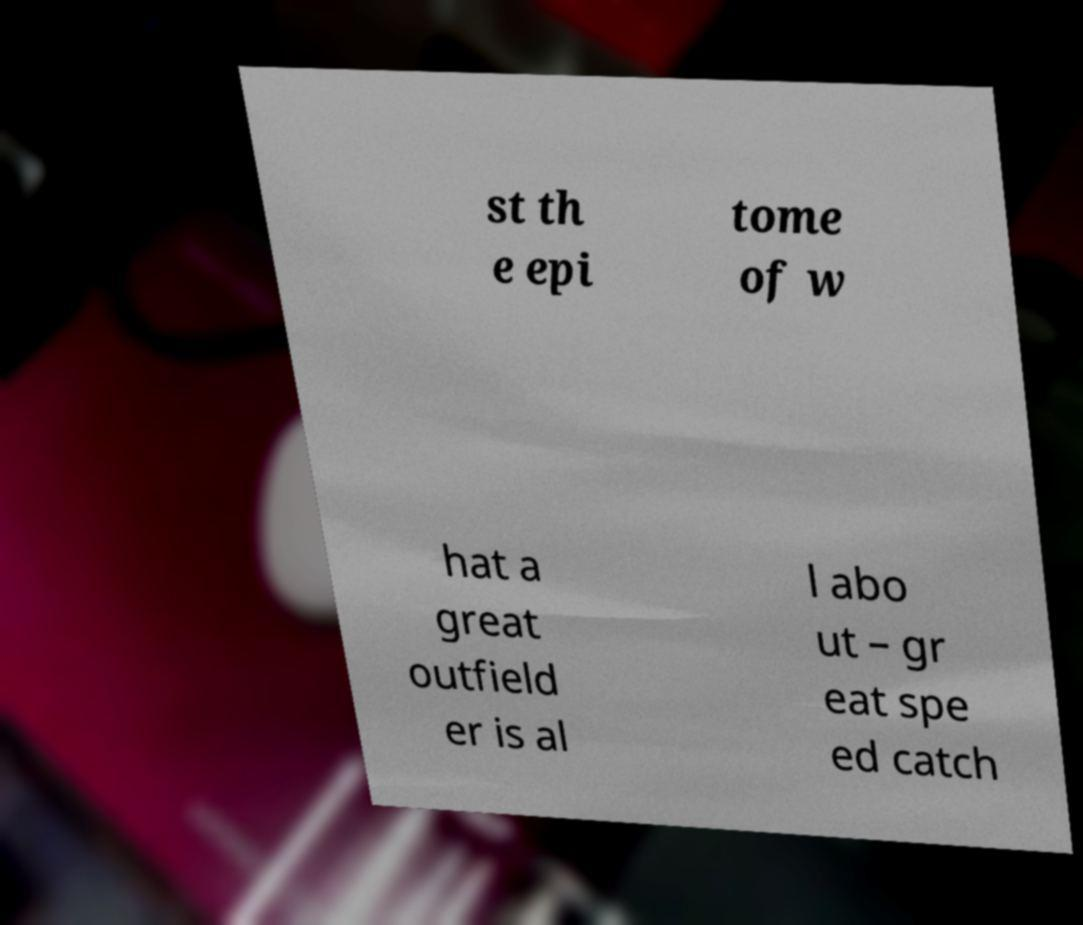What messages or text are displayed in this image? I need them in a readable, typed format. st th e epi tome of w hat a great outfield er is al l abo ut – gr eat spe ed catch 